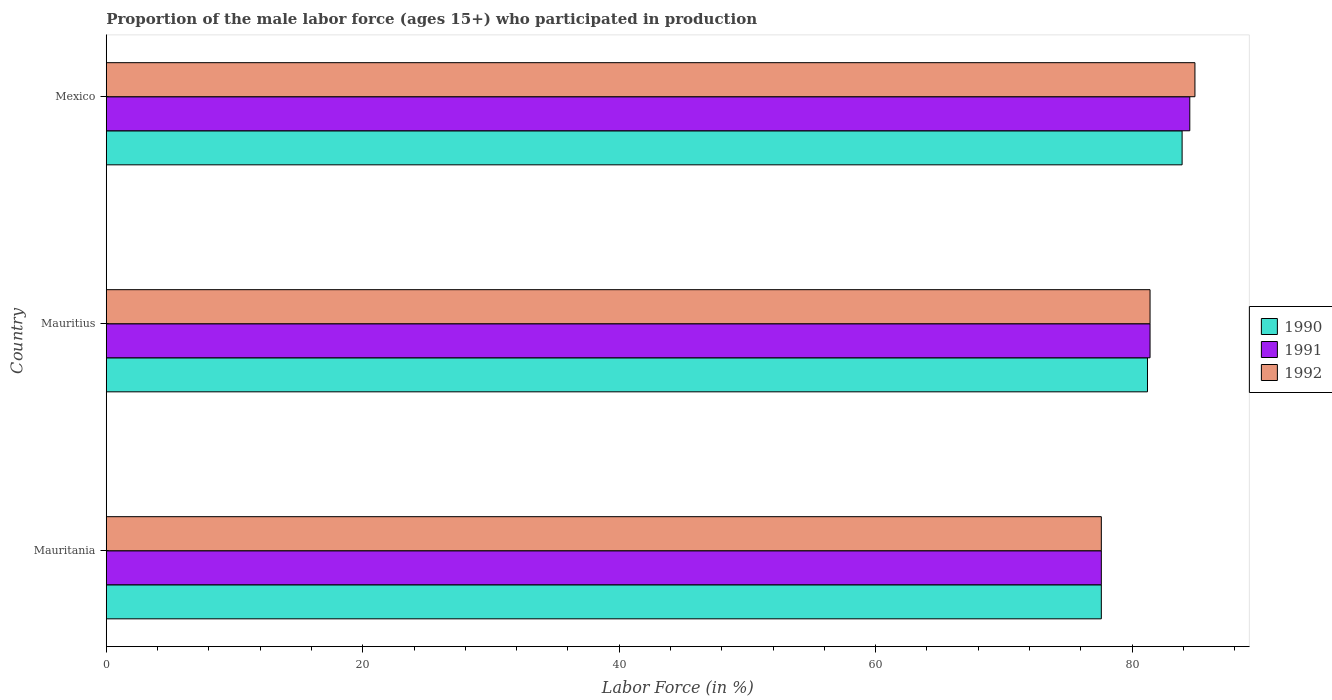How many different coloured bars are there?
Provide a succinct answer. 3. How many groups of bars are there?
Your answer should be compact. 3. Are the number of bars per tick equal to the number of legend labels?
Your answer should be very brief. Yes. How many bars are there on the 1st tick from the bottom?
Your response must be concise. 3. What is the label of the 3rd group of bars from the top?
Ensure brevity in your answer.  Mauritania. What is the proportion of the male labor force who participated in production in 1992 in Mexico?
Your response must be concise. 84.9. Across all countries, what is the maximum proportion of the male labor force who participated in production in 1992?
Offer a terse response. 84.9. Across all countries, what is the minimum proportion of the male labor force who participated in production in 1991?
Keep it short and to the point. 77.6. In which country was the proportion of the male labor force who participated in production in 1990 maximum?
Your response must be concise. Mexico. In which country was the proportion of the male labor force who participated in production in 1991 minimum?
Ensure brevity in your answer.  Mauritania. What is the total proportion of the male labor force who participated in production in 1990 in the graph?
Your answer should be compact. 242.7. What is the difference between the proportion of the male labor force who participated in production in 1992 in Mauritania and that in Mauritius?
Your answer should be compact. -3.8. What is the difference between the proportion of the male labor force who participated in production in 1990 in Mauritius and the proportion of the male labor force who participated in production in 1991 in Mexico?
Make the answer very short. -3.3. What is the average proportion of the male labor force who participated in production in 1991 per country?
Offer a very short reply. 81.17. What is the ratio of the proportion of the male labor force who participated in production in 1991 in Mauritius to that in Mexico?
Your response must be concise. 0.96. Is the proportion of the male labor force who participated in production in 1992 in Mauritania less than that in Mauritius?
Your answer should be very brief. Yes. Is the difference between the proportion of the male labor force who participated in production in 1991 in Mauritius and Mexico greater than the difference between the proportion of the male labor force who participated in production in 1992 in Mauritius and Mexico?
Offer a very short reply. Yes. What is the difference between the highest and the second highest proportion of the male labor force who participated in production in 1990?
Give a very brief answer. 2.7. What is the difference between the highest and the lowest proportion of the male labor force who participated in production in 1992?
Provide a short and direct response. 7.3. What does the 3rd bar from the top in Mauritania represents?
Your answer should be very brief. 1990. Is it the case that in every country, the sum of the proportion of the male labor force who participated in production in 1992 and proportion of the male labor force who participated in production in 1991 is greater than the proportion of the male labor force who participated in production in 1990?
Ensure brevity in your answer.  Yes. How many bars are there?
Provide a short and direct response. 9. Are all the bars in the graph horizontal?
Provide a short and direct response. Yes. Are the values on the major ticks of X-axis written in scientific E-notation?
Keep it short and to the point. No. Does the graph contain any zero values?
Ensure brevity in your answer.  No. What is the title of the graph?
Your response must be concise. Proportion of the male labor force (ages 15+) who participated in production. Does "1966" appear as one of the legend labels in the graph?
Provide a succinct answer. No. What is the label or title of the X-axis?
Your answer should be very brief. Labor Force (in %). What is the Labor Force (in %) in 1990 in Mauritania?
Offer a very short reply. 77.6. What is the Labor Force (in %) in 1991 in Mauritania?
Make the answer very short. 77.6. What is the Labor Force (in %) in 1992 in Mauritania?
Provide a short and direct response. 77.6. What is the Labor Force (in %) of 1990 in Mauritius?
Keep it short and to the point. 81.2. What is the Labor Force (in %) in 1991 in Mauritius?
Your response must be concise. 81.4. What is the Labor Force (in %) of 1992 in Mauritius?
Ensure brevity in your answer.  81.4. What is the Labor Force (in %) in 1990 in Mexico?
Make the answer very short. 83.9. What is the Labor Force (in %) of 1991 in Mexico?
Provide a short and direct response. 84.5. What is the Labor Force (in %) of 1992 in Mexico?
Make the answer very short. 84.9. Across all countries, what is the maximum Labor Force (in %) of 1990?
Give a very brief answer. 83.9. Across all countries, what is the maximum Labor Force (in %) of 1991?
Make the answer very short. 84.5. Across all countries, what is the maximum Labor Force (in %) of 1992?
Give a very brief answer. 84.9. Across all countries, what is the minimum Labor Force (in %) of 1990?
Offer a terse response. 77.6. Across all countries, what is the minimum Labor Force (in %) of 1991?
Your response must be concise. 77.6. Across all countries, what is the minimum Labor Force (in %) in 1992?
Your answer should be compact. 77.6. What is the total Labor Force (in %) of 1990 in the graph?
Offer a very short reply. 242.7. What is the total Labor Force (in %) in 1991 in the graph?
Provide a short and direct response. 243.5. What is the total Labor Force (in %) in 1992 in the graph?
Offer a terse response. 243.9. What is the difference between the Labor Force (in %) of 1991 in Mauritania and that in Mexico?
Offer a terse response. -6.9. What is the difference between the Labor Force (in %) in 1990 in Mauritius and that in Mexico?
Offer a terse response. -2.7. What is the difference between the Labor Force (in %) in 1991 in Mauritius and that in Mexico?
Your answer should be very brief. -3.1. What is the difference between the Labor Force (in %) of 1992 in Mauritius and that in Mexico?
Keep it short and to the point. -3.5. What is the difference between the Labor Force (in %) in 1990 in Mauritania and the Labor Force (in %) in 1991 in Mauritius?
Your answer should be compact. -3.8. What is the difference between the Labor Force (in %) of 1991 in Mauritania and the Labor Force (in %) of 1992 in Mauritius?
Offer a terse response. -3.8. What is the difference between the Labor Force (in %) in 1990 in Mauritania and the Labor Force (in %) in 1991 in Mexico?
Offer a very short reply. -6.9. What is the difference between the Labor Force (in %) in 1990 in Mauritania and the Labor Force (in %) in 1992 in Mexico?
Offer a terse response. -7.3. What is the difference between the Labor Force (in %) of 1991 in Mauritania and the Labor Force (in %) of 1992 in Mexico?
Make the answer very short. -7.3. What is the difference between the Labor Force (in %) of 1990 in Mauritius and the Labor Force (in %) of 1992 in Mexico?
Your answer should be compact. -3.7. What is the average Labor Force (in %) in 1990 per country?
Provide a succinct answer. 80.9. What is the average Labor Force (in %) in 1991 per country?
Offer a terse response. 81.17. What is the average Labor Force (in %) in 1992 per country?
Your response must be concise. 81.3. What is the difference between the Labor Force (in %) in 1990 and Labor Force (in %) in 1991 in Mauritania?
Your answer should be very brief. 0. What is the difference between the Labor Force (in %) of 1990 and Labor Force (in %) of 1992 in Mauritania?
Offer a terse response. 0. What is the difference between the Labor Force (in %) of 1990 and Labor Force (in %) of 1991 in Mauritius?
Your answer should be compact. -0.2. What is the difference between the Labor Force (in %) of 1991 and Labor Force (in %) of 1992 in Mauritius?
Provide a succinct answer. 0. What is the difference between the Labor Force (in %) of 1991 and Labor Force (in %) of 1992 in Mexico?
Your answer should be compact. -0.4. What is the ratio of the Labor Force (in %) of 1990 in Mauritania to that in Mauritius?
Your response must be concise. 0.96. What is the ratio of the Labor Force (in %) in 1991 in Mauritania to that in Mauritius?
Keep it short and to the point. 0.95. What is the ratio of the Labor Force (in %) in 1992 in Mauritania to that in Mauritius?
Make the answer very short. 0.95. What is the ratio of the Labor Force (in %) in 1990 in Mauritania to that in Mexico?
Offer a terse response. 0.92. What is the ratio of the Labor Force (in %) in 1991 in Mauritania to that in Mexico?
Provide a short and direct response. 0.92. What is the ratio of the Labor Force (in %) in 1992 in Mauritania to that in Mexico?
Offer a terse response. 0.91. What is the ratio of the Labor Force (in %) in 1990 in Mauritius to that in Mexico?
Keep it short and to the point. 0.97. What is the ratio of the Labor Force (in %) in 1991 in Mauritius to that in Mexico?
Your answer should be compact. 0.96. What is the ratio of the Labor Force (in %) of 1992 in Mauritius to that in Mexico?
Ensure brevity in your answer.  0.96. What is the difference between the highest and the second highest Labor Force (in %) in 1992?
Offer a very short reply. 3.5. What is the difference between the highest and the lowest Labor Force (in %) of 1991?
Give a very brief answer. 6.9. 